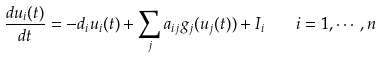Convert formula to latex. <formula><loc_0><loc_0><loc_500><loc_500>\frac { d u _ { i } ( t ) } { d t } = - d _ { i } u _ { i } ( t ) + \sum _ { j } a _ { i j } g _ { j } ( u _ { j } ( t ) ) + I _ { i } \quad i = 1 , \cdots , n</formula> 